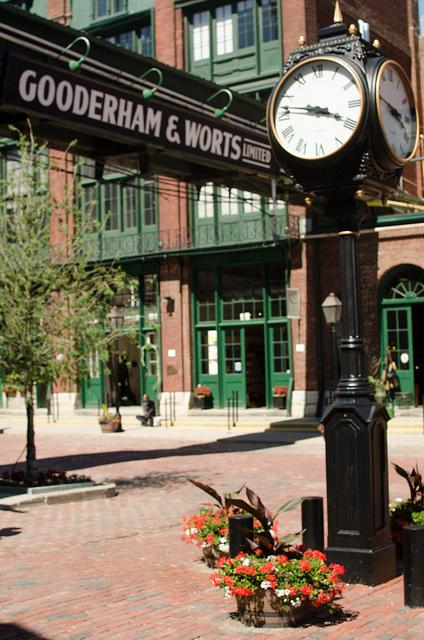In which setting is this clock? city 